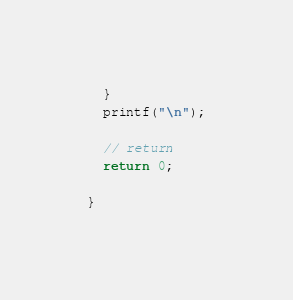Convert code to text. <code><loc_0><loc_0><loc_500><loc_500><_Cuda_>  }
  printf("\n");

  // return 
  return 0;

}

</code> 